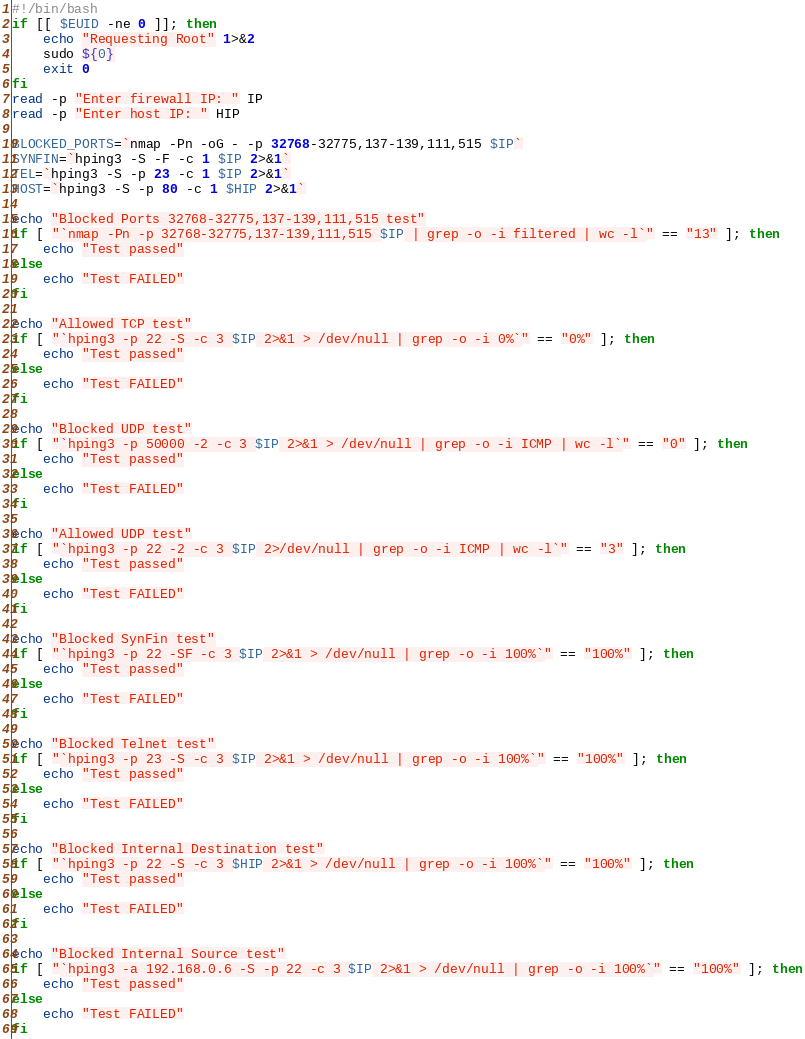Convert code to text. <code><loc_0><loc_0><loc_500><loc_500><_Bash_>#!/bin/bash
if [[ $EUID -ne 0 ]]; then
    echo "Requesting Root" 1>&2
    sudo ${0}
    exit 0
fi
read -p "Enter firewall IP: " IP
read -p "Enter host IP: " HIP

BLOCKED_PORTS=`nmap -Pn -oG - -p 32768-32775,137-139,111,515 $IP`
SYNFIN=`hping3 -S -F -c 1 $IP 2>&1`
TEL=`hping3 -S -p 23 -c 1 $IP 2>&1`
HOST=`hping3 -S -p 80 -c 1 $HIP 2>&1`

echo "Blocked Ports 32768-32775,137-139,111,515 test"
if [ "`nmap -Pn -p 32768-32775,137-139,111,515 $IP | grep -o -i filtered | wc -l`" == "13" ]; then
    echo "Test passed"
else
    echo "Test FAILED"
fi

echo "Allowed TCP test"
if [ "`hping3 -p 22 -S -c 3 $IP 2>&1 > /dev/null | grep -o -i 0%`" == "0%" ]; then
    echo "Test passed"
else
    echo "Test FAILED"
fi

echo "Blocked UDP test"
if [ "`hping3 -p 50000 -2 -c 3 $IP 2>&1 > /dev/null | grep -o -i ICMP | wc -l`" == "0" ]; then
    echo "Test passed"
else
    echo "Test FAILED"
fi

echo "Allowed UDP test"
if [ "`hping3 -p 22 -2 -c 3 $IP 2>/dev/null | grep -o -i ICMP | wc -l`" == "3" ]; then
    echo "Test passed"
else
    echo "Test FAILED"
fi

echo "Blocked SynFin test"
if [ "`hping3 -p 22 -SF -c 3 $IP 2>&1 > /dev/null | grep -o -i 100%`" == "100%" ]; then
    echo "Test passed"
else
    echo "Test FAILED"
fi

echo "Blocked Telnet test"
if [ "`hping3 -p 23 -S -c 3 $IP 2>&1 > /dev/null | grep -o -i 100%`" == "100%" ]; then
    echo "Test passed"
else
    echo "Test FAILED"
fi

echo "Blocked Internal Destination test"
if [ "`hping3 -p 22 -S -c 3 $HIP 2>&1 > /dev/null | grep -o -i 100%`" == "100%" ]; then
    echo "Test passed"
else
    echo "Test FAILED"
fi

echo "Blocked Internal Source test"
if [ "`hping3 -a 192.168.0.6 -S -p 22 -c 3 $IP 2>&1 > /dev/null | grep -o -i 100%`" == "100%" ]; then
    echo "Test passed"
else
    echo "Test FAILED"
fi
</code> 